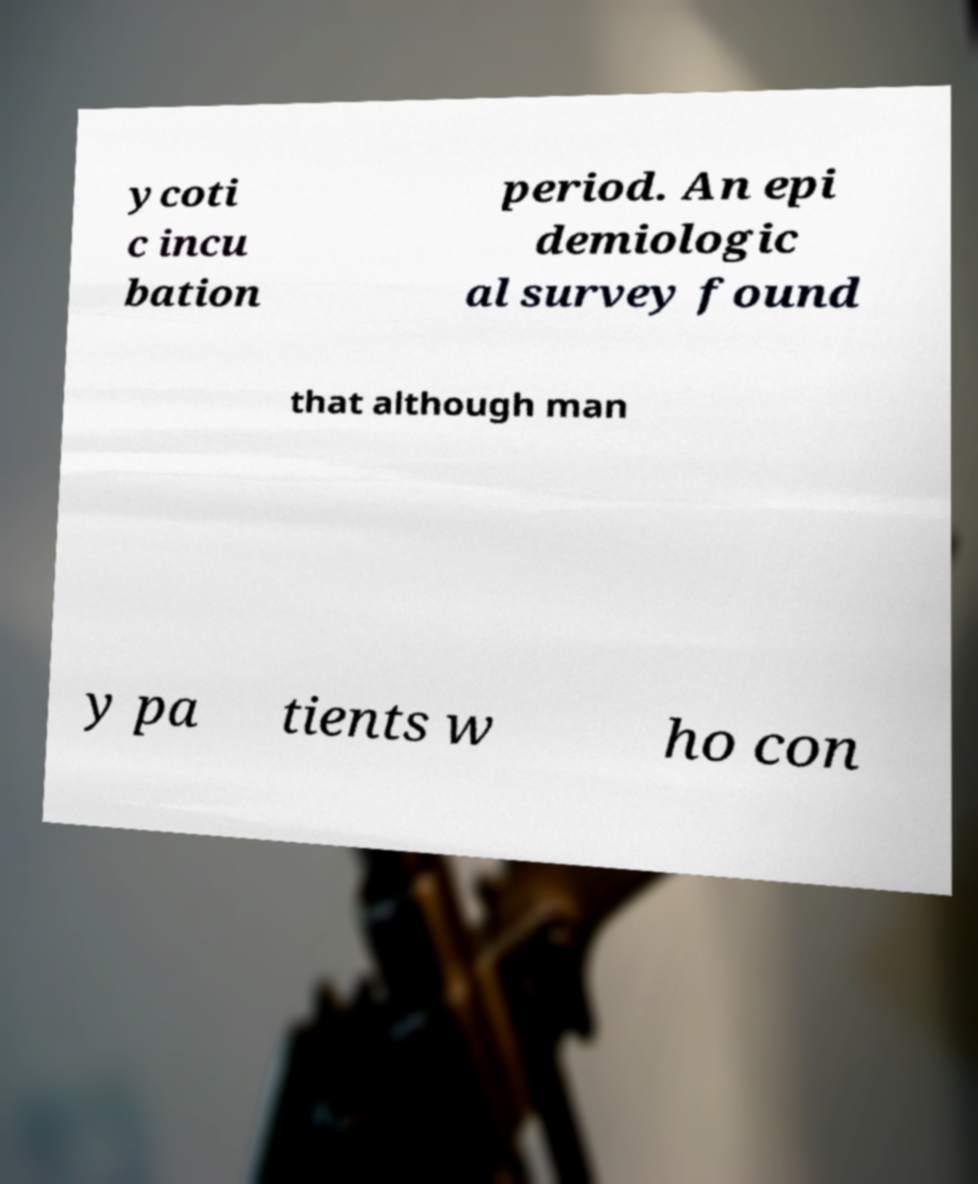For documentation purposes, I need the text within this image transcribed. Could you provide that? ycoti c incu bation period. An epi demiologic al survey found that although man y pa tients w ho con 